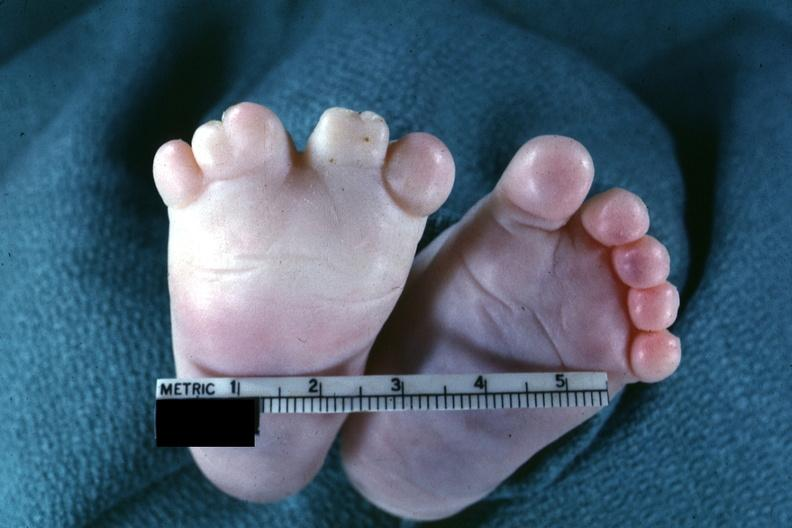does yo show very good example of syndactyly?
Answer the question using a single word or phrase. No 